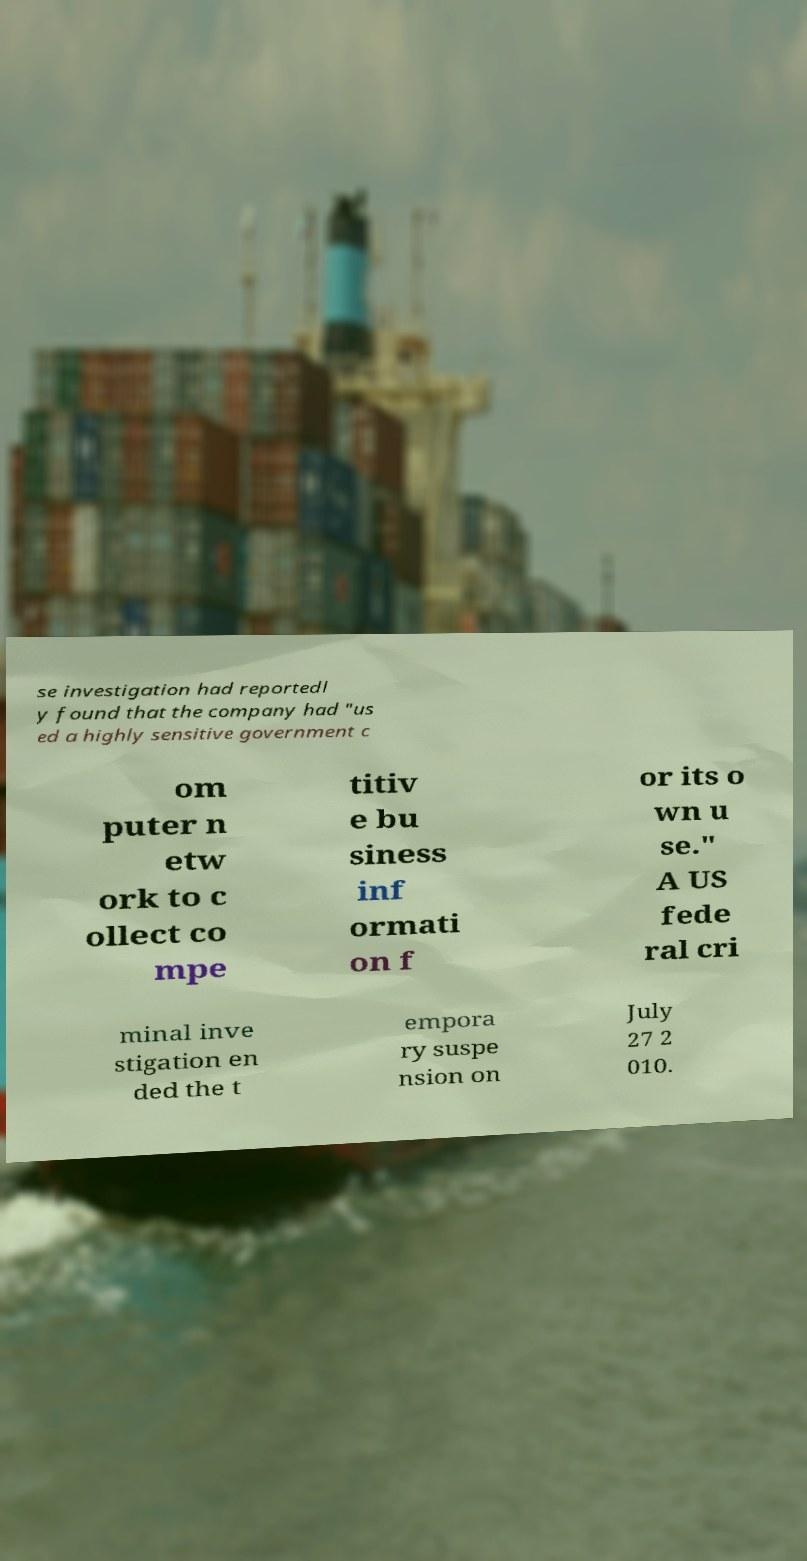Could you extract and type out the text from this image? se investigation had reportedl y found that the company had "us ed a highly sensitive government c om puter n etw ork to c ollect co mpe titiv e bu siness inf ormati on f or its o wn u se." A US fede ral cri minal inve stigation en ded the t empora ry suspe nsion on July 27 2 010. 